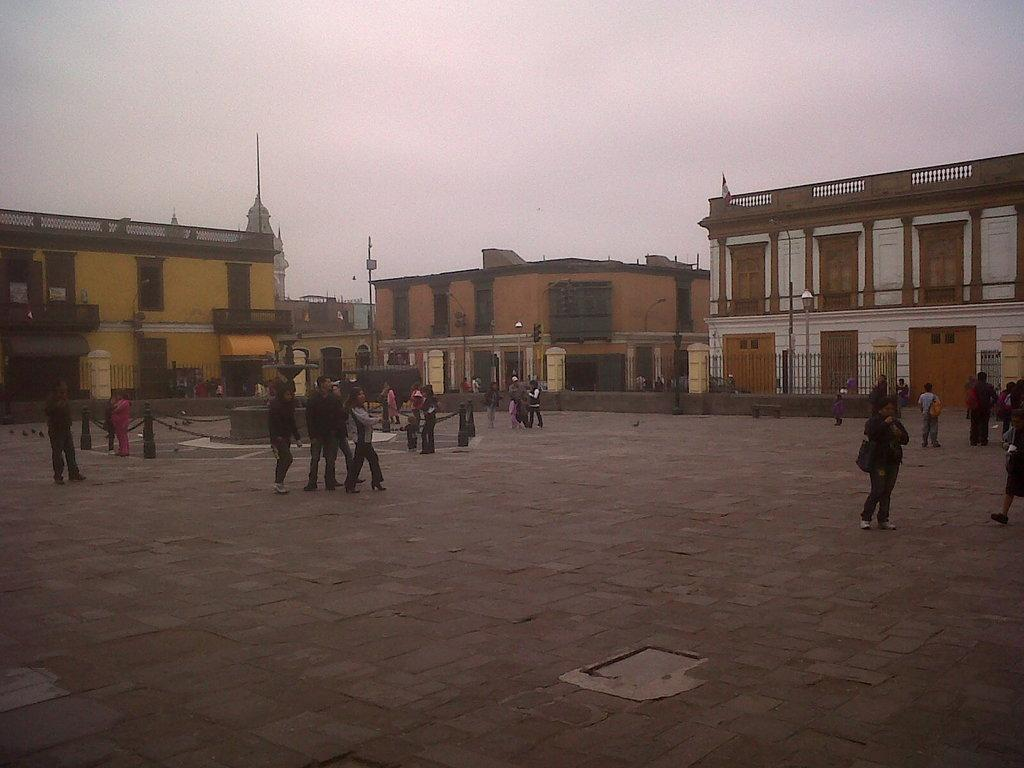What type of structures can be seen in the image? There are buildings in the image. What else can be seen in the image besides buildings? There are poles, a fence, people standing on the ground, and other objects in the image. Where are the people located in the image? The people are standing on the ground in the image. What is visible in the background of the image? The sky is visible in the background of the image. What type of hammer is being used to break the wall in the image? There is no hammer or wall present in the image. How does the flight of birds affect the scene in the image? There are no birds or flight in the image; it features buildings, poles, a fence, people, and other objects. 